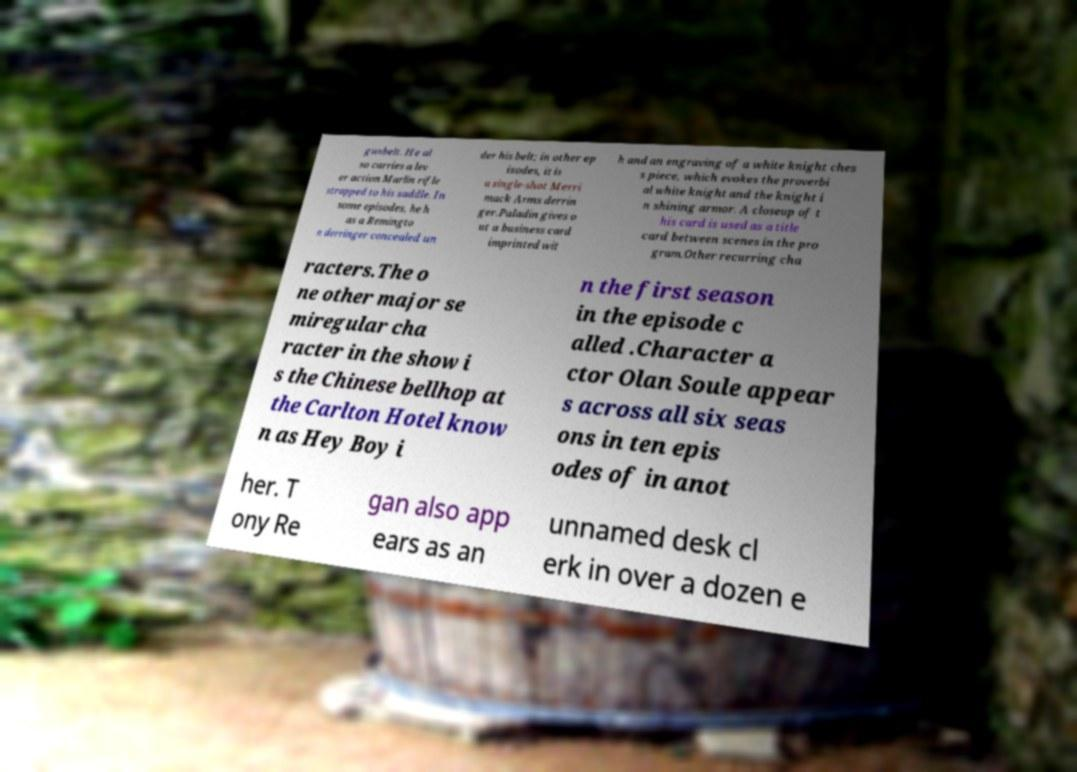Can you accurately transcribe the text from the provided image for me? gunbelt. He al so carries a lev er action Marlin rifle strapped to his saddle. In some episodes, he h as a Remingto n derringer concealed un der his belt; in other ep isodes, it is a single-shot Merri mack Arms derrin ger.Paladin gives o ut a business card imprinted wit h and an engraving of a white knight ches s piece, which evokes the proverbi al white knight and the knight i n shining armor. A closeup of t his card is used as a title card between scenes in the pro gram.Other recurring cha racters.The o ne other major se miregular cha racter in the show i s the Chinese bellhop at the Carlton Hotel know n as Hey Boy i n the first season in the episode c alled .Character a ctor Olan Soule appear s across all six seas ons in ten epis odes of in anot her. T ony Re gan also app ears as an unnamed desk cl erk in over a dozen e 